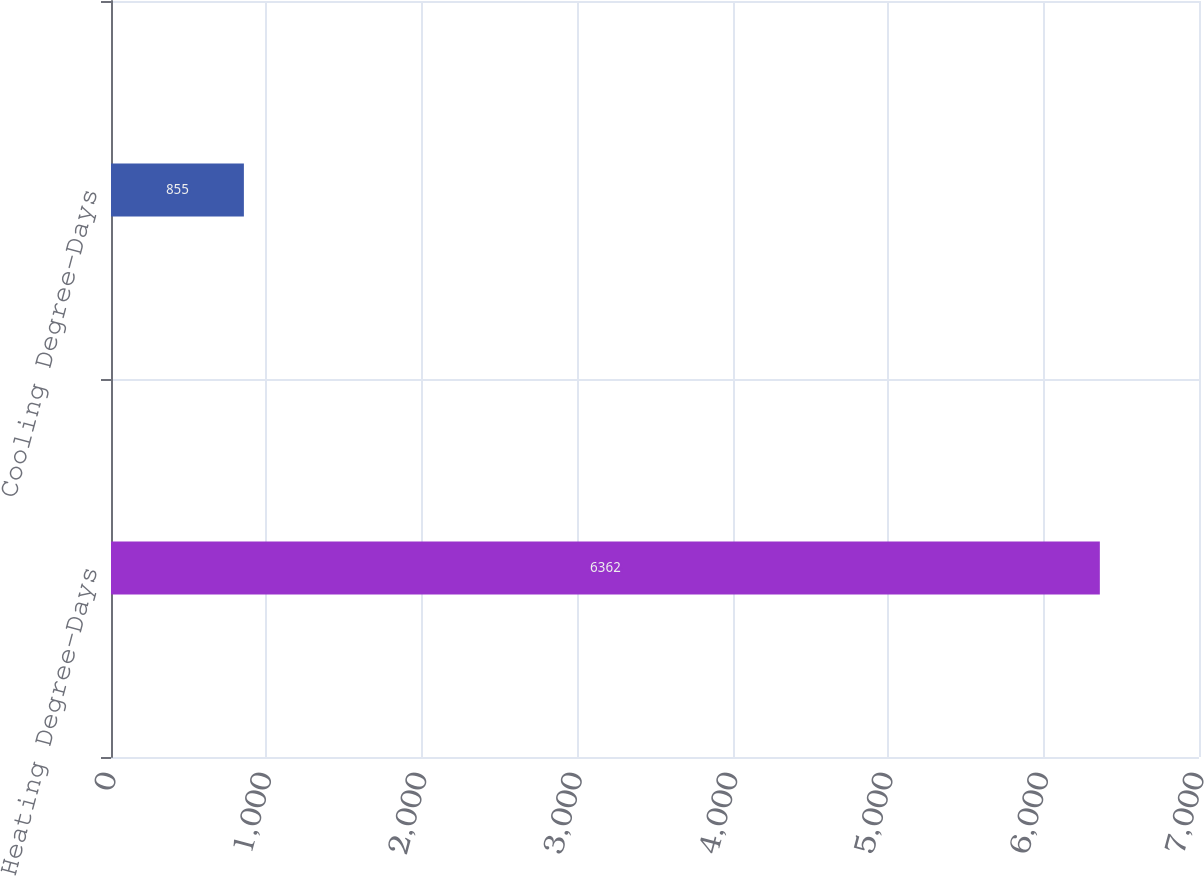Convert chart. <chart><loc_0><loc_0><loc_500><loc_500><bar_chart><fcel>Heating Degree-Days<fcel>Cooling Degree-Days<nl><fcel>6362<fcel>855<nl></chart> 